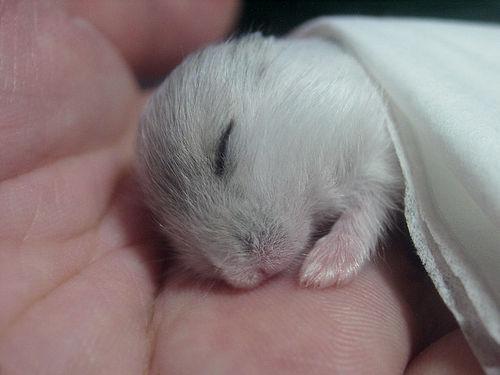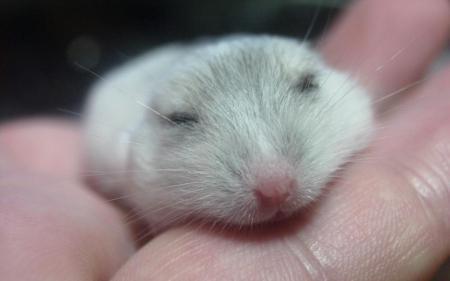The first image is the image on the left, the second image is the image on the right. For the images displayed, is the sentence "Each image shows a hand holding exactly one pet rodent, and each pet rodent is held, but not grasped, in an upturned hand." factually correct? Answer yes or no. Yes. The first image is the image on the left, the second image is the image on the right. For the images displayed, is the sentence "The hamsters are all the same color." factually correct? Answer yes or no. Yes. 